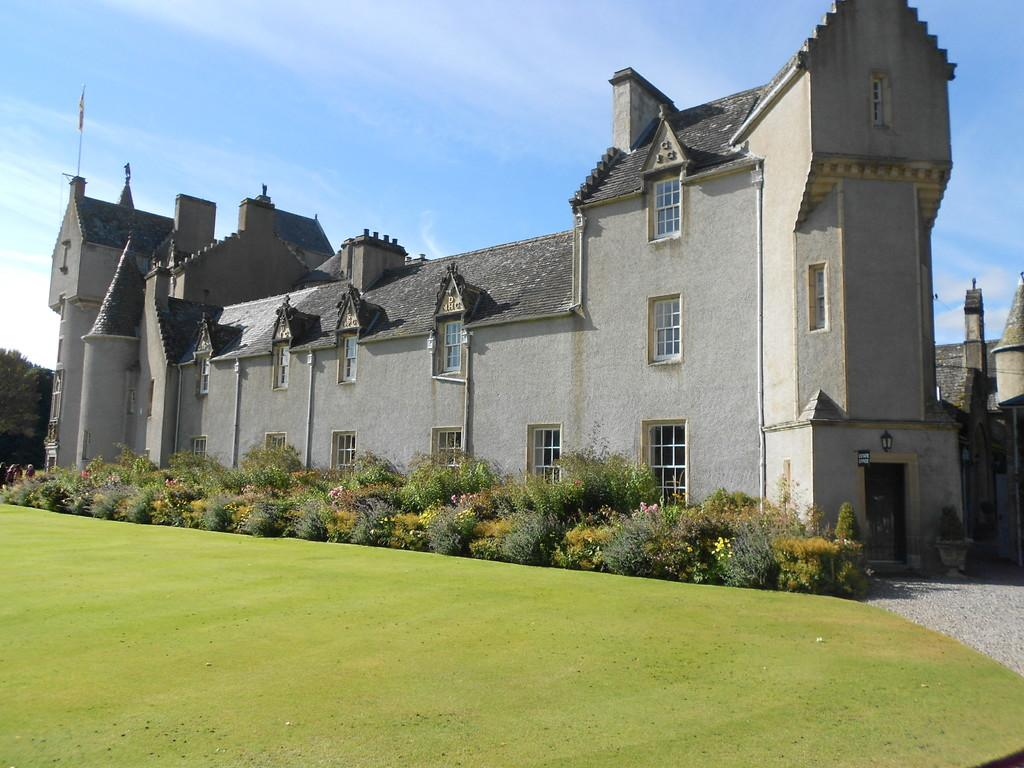What type of vegetation is present in the image? There is grass and plants in the image. What type of structure can be seen in the image? There is a building in the image. What can be seen in the background of the image? The sky is visible in the background of the image. What type of soup is being served in the image? There is no soup present in the image. What is the process for growing the plants in the image? The image does not provide information about the process for growing the plants. 